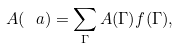Convert formula to latex. <formula><loc_0><loc_0><loc_500><loc_500>A ( \ a ) = \sum _ { \Gamma } A ( \Gamma ) f ( \Gamma ) ,</formula> 